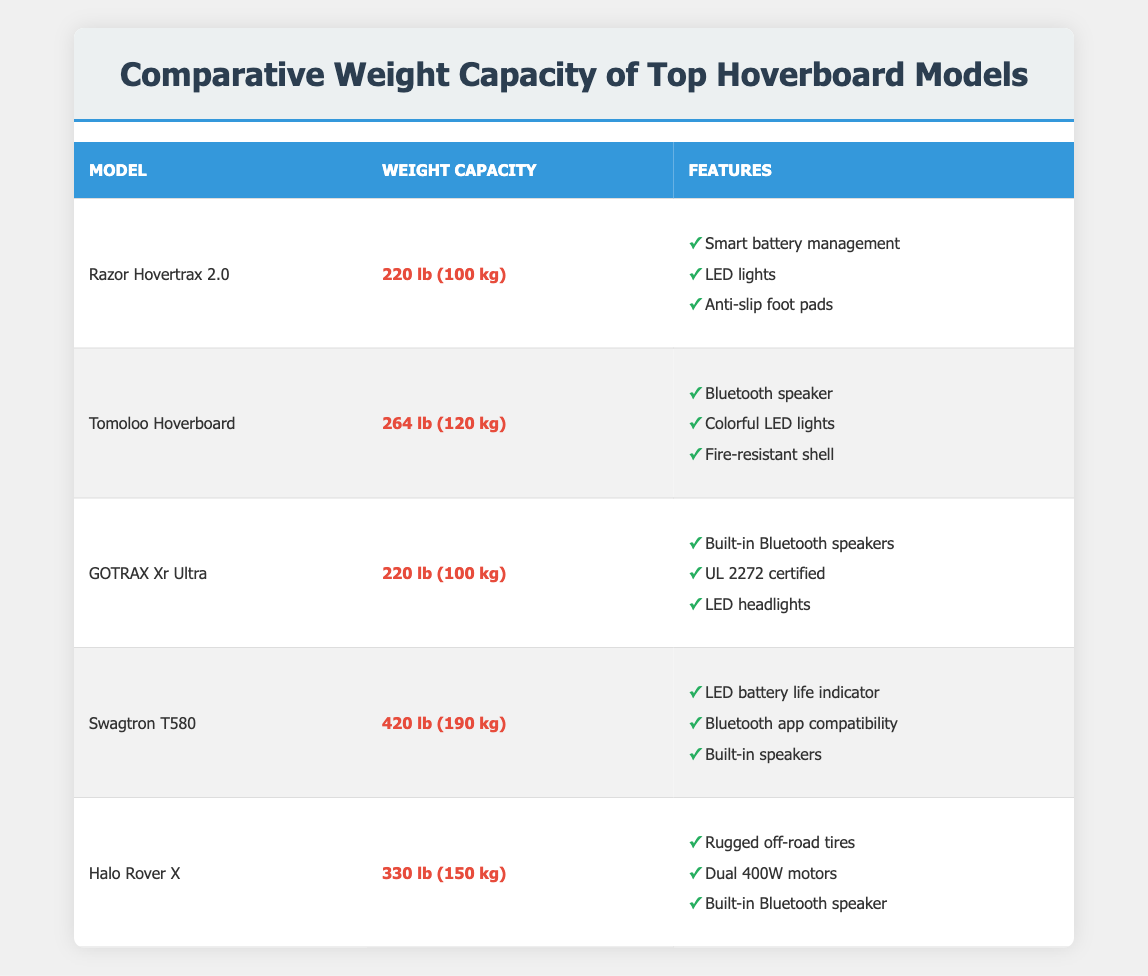What is the weight capacity of the Razor Hovertrax 2.0? The table lists the weight capacity of the Razor Hovertrax 2.0 as 220 lb (100 kg).
Answer: 220 lb (100 kg) Which hoverboard has the highest weight capacity? By comparing the weight capacities in the table, the Swagtron T580 has the highest capacity at 420 lb (190 kg).
Answer: Swagtron T580 What are the features of the Tomoloo Hoverboard? The table lists the features of the Tomoloo Hoverboard as: Bluetooth speaker, Colorful LED lights, and Fire-resistant shell.
Answer: Bluetooth speaker, Colorful LED lights, Fire-resistant shell Is the weight capacity of the GOTRAX Xr Ultra the same as the Razor Hovertrax 2.0? Yes, both the GOTRAX Xr Ultra and the Razor Hovertrax 2.0 have a weight capacity of 220 lb (100 kg), making them equal.
Answer: Yes What is the average weight capacity of the hoverboards listed? To calculate the average, first, sum the weight capacities: 220 + 264 + 220 + 420 + 330 = 1454 lb. Then, divide by the number of models (5): 1454 / 5 = 290.8 lb.
Answer: 290.8 lb How many hoverboards have a weight capacity of over 300 lb? Checking the table reveals two hoverboards with a capacity exceeding 300 lb: the Swagtron T580 and the Halo Rover X. Therefore, the total is 2.
Answer: 2 Does the Halo Rover X have built-in Bluetooth speakers? Yes, the features list for the Halo Rover X includes a built-in Bluetooth speaker.
Answer: Yes What is the difference in weight capacity between the Swagtron T580 and the Tomoloo Hoverboard? The weight capacity of Swagtron T580 is 420 lb and that of Tomoloo Hoverboard is 264 lb. The difference is 420 - 264 = 156 lb.
Answer: 156 lb How many hoverboards can support a weight capacity of 250 lb or more? The hoverboards that meet this criteria are: Tomoloo Hoverboard (264 lb), Swagtron T580 (420 lb), and Halo Rover X (330 lb). This gives a total of 3 models.
Answer: 3 What features does the Swagtron T580 have? The features of the Swagtron T580, as per the table, include: LED battery life indicator, Bluetooth app compatibility, and built-in speakers.
Answer: LED battery life indicator, Bluetooth app compatibility, built-in speakers 